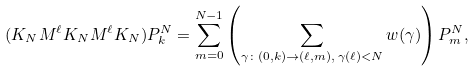Convert formula to latex. <formula><loc_0><loc_0><loc_500><loc_500>( K _ { N } M ^ { \ell } K _ { N } M ^ { \ell } K _ { N } ) P _ { k } ^ { N } = \sum _ { m = 0 } ^ { N - 1 } \left ( \sum _ { \gamma \colon ( 0 , k ) \rightarrow ( \ell , m ) , \, \gamma ( \ell ) < N } w ( \gamma ) \right ) P _ { m } ^ { N } ,</formula> 